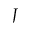<formula> <loc_0><loc_0><loc_500><loc_500>J</formula> 